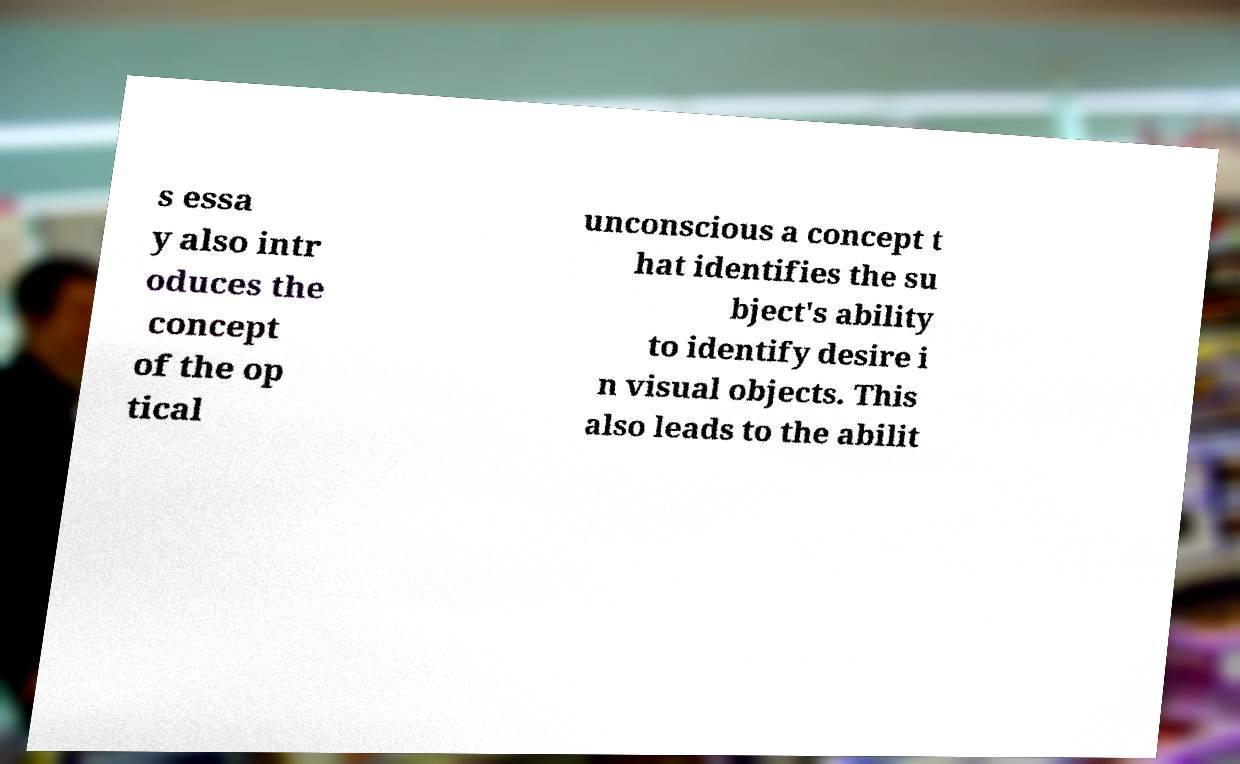Could you assist in decoding the text presented in this image and type it out clearly? s essa y also intr oduces the concept of the op tical unconscious a concept t hat identifies the su bject's ability to identify desire i n visual objects. This also leads to the abilit 